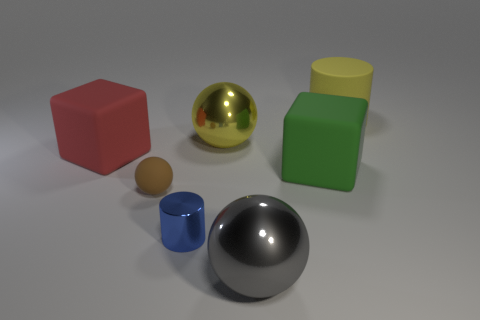The rubber sphere is what color?
Offer a terse response. Brown. Does the rubber cylinder have the same color as the large metallic sphere that is behind the blue metal object?
Provide a short and direct response. Yes. Is there a red rubber object of the same size as the green matte thing?
Ensure brevity in your answer.  Yes. What size is the sphere that is the same color as the matte cylinder?
Ensure brevity in your answer.  Large. What material is the ball behind the red object?
Provide a short and direct response. Metal. Are there an equal number of gray spheres that are left of the blue cylinder and yellow things to the left of the big red matte block?
Offer a very short reply. Yes. There is a rubber cube that is to the left of the blue metal cylinder; does it have the same size as the metallic object that is behind the small brown ball?
Give a very brief answer. Yes. How many small shiny cylinders are the same color as the tiny matte object?
Offer a terse response. 0. There is a thing that is the same color as the large rubber cylinder; what is its material?
Make the answer very short. Metal. Is the number of large shiny spheres in front of the yellow shiny ball greater than the number of tiny cyan shiny objects?
Make the answer very short. Yes. 